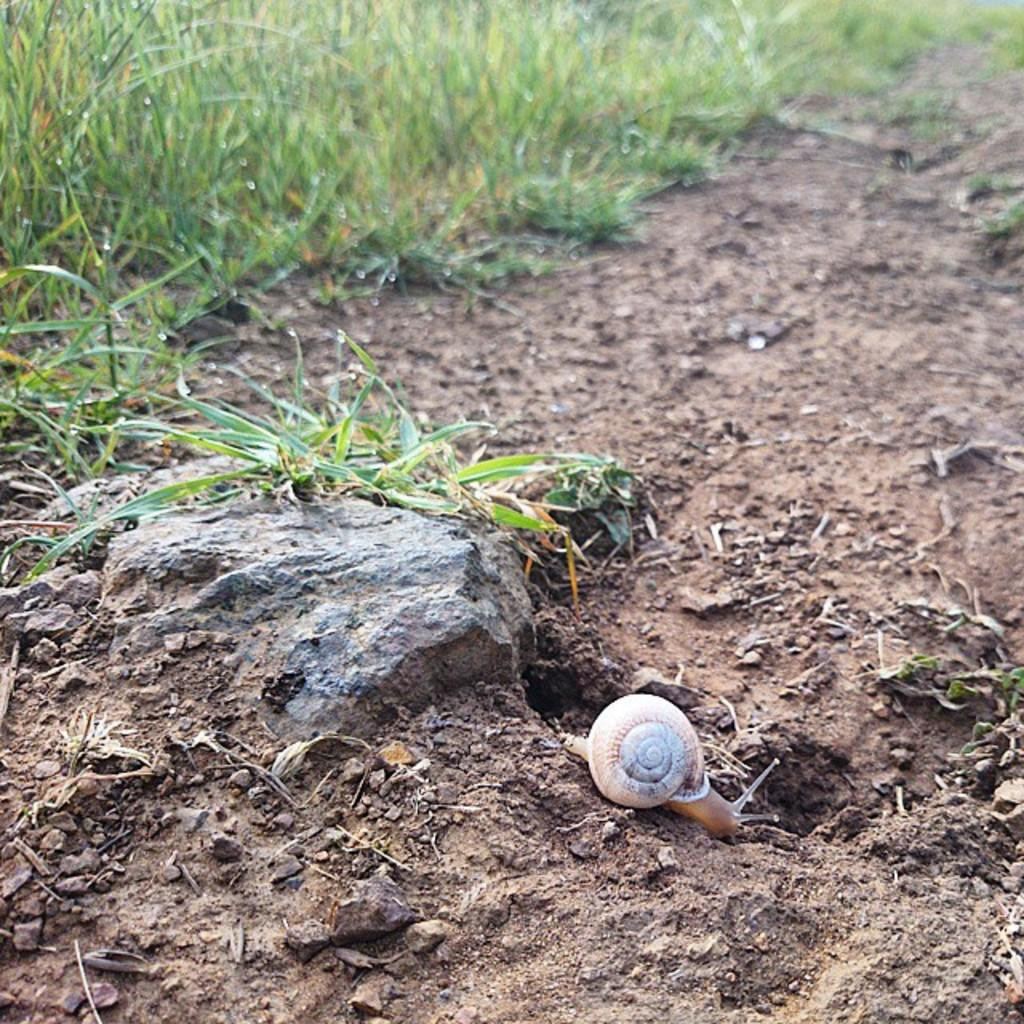What object can be seen on the ground in the image? There is a shell on the ground in the image. What is the color of the shell? The shell is brown in color. What other object is visible in the image? There is a rock visible in the image. What type of vegetation is present in the image? Green color grass is present in the image. How many eggs are hidden in the grass in the image? There are no eggs visible in the image; it only features a shell, a rock, and green color grass. 